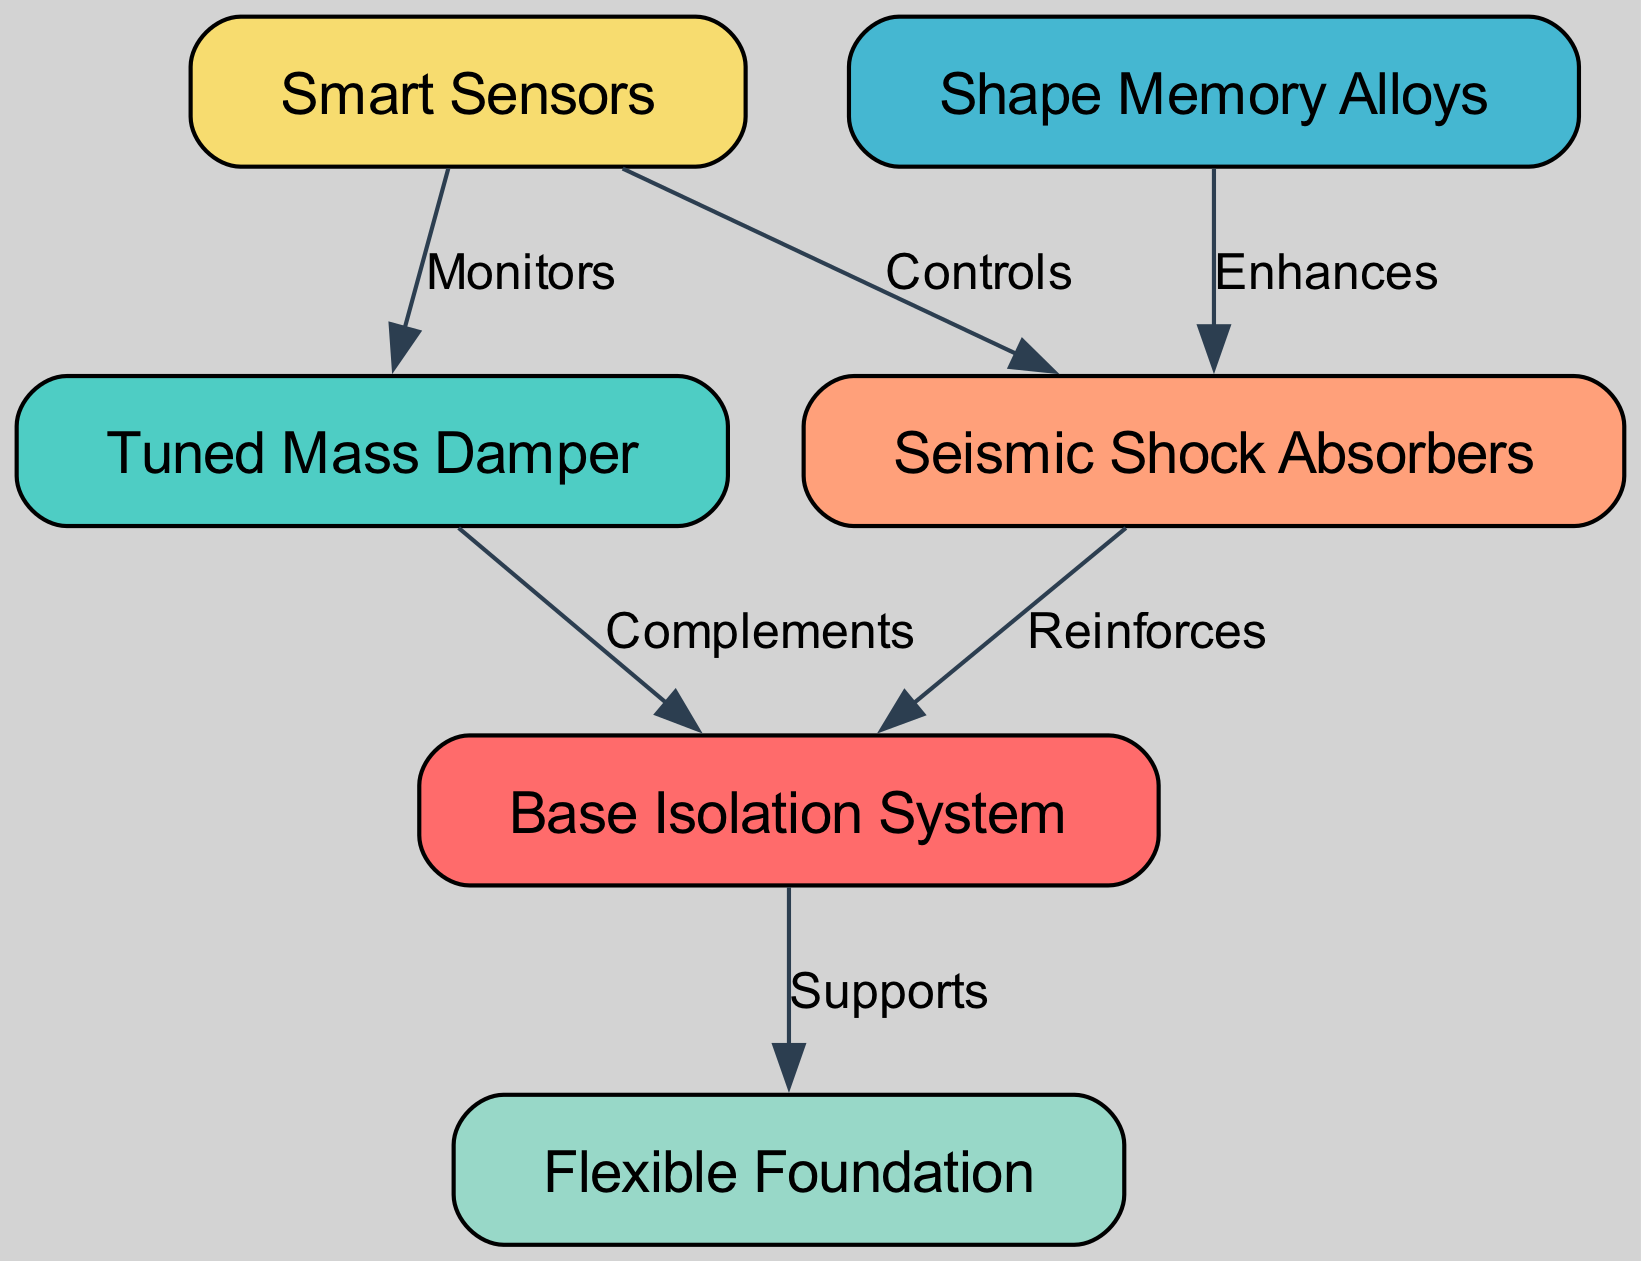What is the total number of nodes in the diagram? The diagram contains a list of nodes within the data structure. Counting them reveals a total of six distinct nodes: Base Isolation System, Tuned Mass Damper, Shape Memory Alloys, Seismic Shock Absorbers, Flexible Foundation, and Smart Sensors.
Answer: 6 Which node does the Base Isolation System support? The diagram specifies a direct relationship indicating that the Base Isolation System supports the Flexible Foundation, represented by the connecting edge labeled "Supports" between these two nodes.
Answer: Flexible Foundation How many edges are connected to the Tuned Mass Damper? By examining the edges associated with the Tuned Mass Damper, we find there are two edges: one connecting it to the Base Isolation System and another connecting it to the Smart Sensors. Therefore, the total number of edges is two.
Answer: 2 What is the relationship between Shape Memory Alloys and Seismic Shock Absorbers? According to the diagram, Shape Memory Alloys enhance the functionality of Seismic Shock Absorbers, represented by the directed edge labeled "Enhances" from Shape Memory Alloys to Seismic Shock Absorbers.
Answer: Enhances Which node monitors the Tuned Mass Damper? The diagram shows a connection between Smart Sensors and Tuned Mass Damper, indicating that Smart Sensors are responsible for monitoring the Tuned Mass Damper, as denoted by the edge labeled "Monitors."
Answer: Smart Sensors What are the two roles of Smart Sensors as shown in the diagram? Looking at the edges emanating from Smart Sensors, we see that they monitor the Tuned Mass Damper and control the Seismic Shock Absorbers. Therefore, their two roles can be summarized as monitoring and controlling.
Answer: Monitoring and controlling 